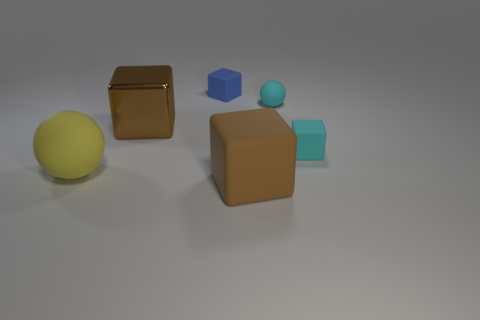Subtract all large brown matte blocks. How many blocks are left? 3 Subtract all cyan cubes. How many cubes are left? 3 Add 1 big brown matte blocks. How many objects exist? 7 Subtract all yellow cubes. Subtract all gray cylinders. How many cubes are left? 4 Subtract all balls. How many objects are left? 4 Add 3 big yellow balls. How many big yellow balls are left? 4 Add 3 brown matte cylinders. How many brown matte cylinders exist? 3 Subtract 1 brown cubes. How many objects are left? 5 Subtract all yellow objects. Subtract all cyan blocks. How many objects are left? 4 